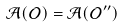Convert formula to latex. <formula><loc_0><loc_0><loc_500><loc_500>\mathcal { A } ( \mathcal { O } ) = \mathcal { A } ( \mathcal { O } ^ { \prime \prime } )</formula> 